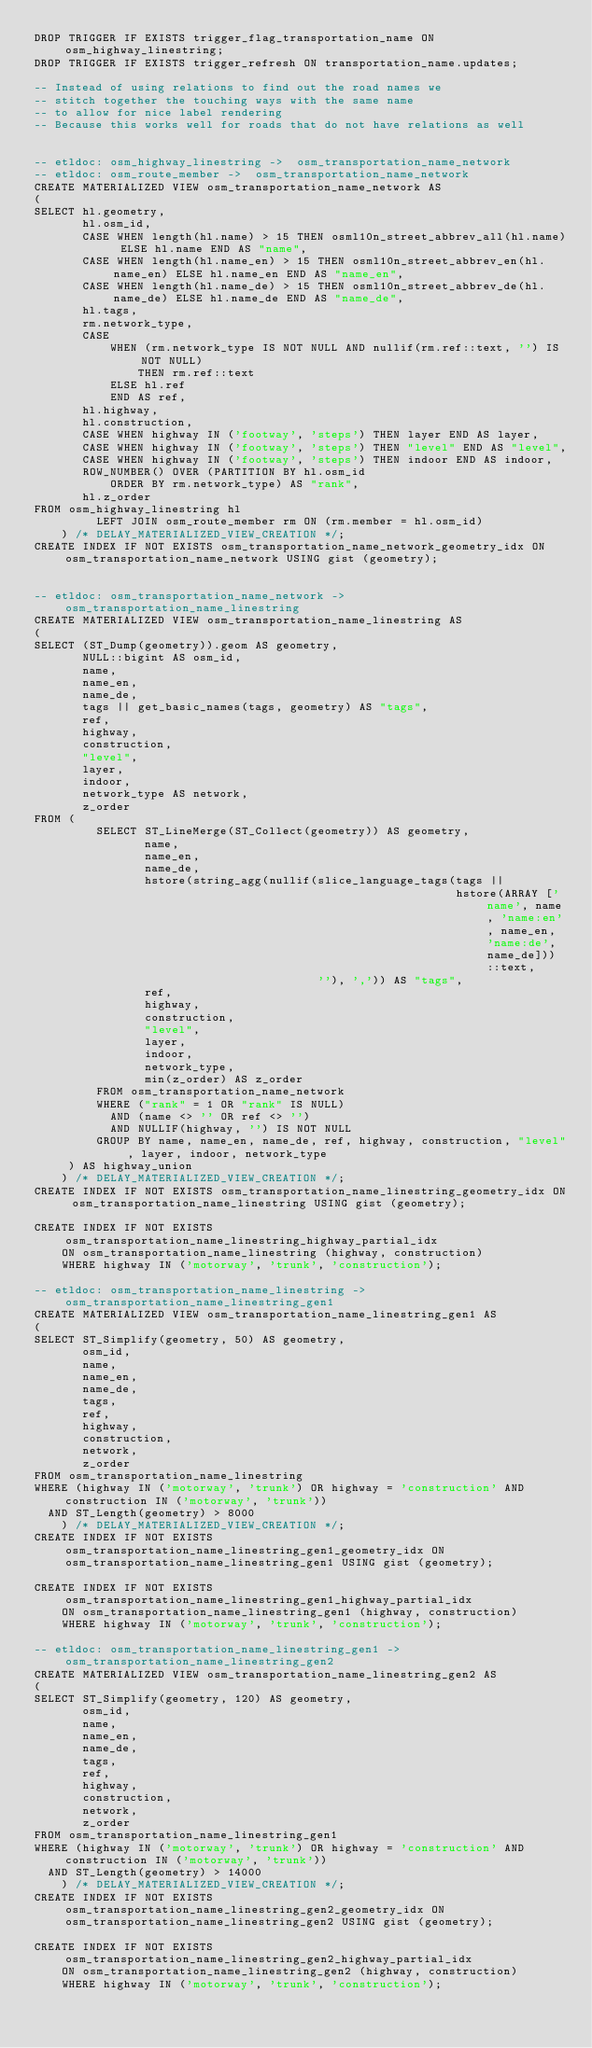<code> <loc_0><loc_0><loc_500><loc_500><_SQL_>DROP TRIGGER IF EXISTS trigger_flag_transportation_name ON osm_highway_linestring;
DROP TRIGGER IF EXISTS trigger_refresh ON transportation_name.updates;

-- Instead of using relations to find out the road names we
-- stitch together the touching ways with the same name
-- to allow for nice label rendering
-- Because this works well for roads that do not have relations as well


-- etldoc: osm_highway_linestring ->  osm_transportation_name_network
-- etldoc: osm_route_member ->  osm_transportation_name_network
CREATE MATERIALIZED VIEW osm_transportation_name_network AS
(
SELECT hl.geometry,
       hl.osm_id,
       CASE WHEN length(hl.name) > 15 THEN osml10n_street_abbrev_all(hl.name) ELSE hl.name END AS "name",
       CASE WHEN length(hl.name_en) > 15 THEN osml10n_street_abbrev_en(hl.name_en) ELSE hl.name_en END AS "name_en",
       CASE WHEN length(hl.name_de) > 15 THEN osml10n_street_abbrev_de(hl.name_de) ELSE hl.name_de END AS "name_de",
       hl.tags,
       rm.network_type,
       CASE
           WHEN (rm.network_type IS NOT NULL AND nullif(rm.ref::text, '') IS NOT NULL)
               THEN rm.ref::text
           ELSE hl.ref
           END AS ref,
       hl.highway,
       hl.construction,
       CASE WHEN highway IN ('footway', 'steps') THEN layer END AS layer,
       CASE WHEN highway IN ('footway', 'steps') THEN "level" END AS "level",
       CASE WHEN highway IN ('footway', 'steps') THEN indoor END AS indoor,
       ROW_NUMBER() OVER (PARTITION BY hl.osm_id
           ORDER BY rm.network_type) AS "rank",
       hl.z_order
FROM osm_highway_linestring hl
         LEFT JOIN osm_route_member rm ON (rm.member = hl.osm_id)
    ) /* DELAY_MATERIALIZED_VIEW_CREATION */;
CREATE INDEX IF NOT EXISTS osm_transportation_name_network_geometry_idx ON osm_transportation_name_network USING gist (geometry);


-- etldoc: osm_transportation_name_network ->  osm_transportation_name_linestring
CREATE MATERIALIZED VIEW osm_transportation_name_linestring AS
(
SELECT (ST_Dump(geometry)).geom AS geometry,
       NULL::bigint AS osm_id,
       name,
       name_en,
       name_de,
       tags || get_basic_names(tags, geometry) AS "tags",
       ref,
       highway,
       construction,
       "level",
       layer,
       indoor,
       network_type AS network,
       z_order
FROM (
         SELECT ST_LineMerge(ST_Collect(geometry)) AS geometry,
                name,
                name_en,
                name_de,
                hstore(string_agg(nullif(slice_language_tags(tags ||
                                                             hstore(ARRAY ['name', name, 'name:en', name_en, 'name:de', name_de]))::text,
                                         ''), ',')) AS "tags",
                ref,
                highway,
                construction,
                "level",
                layer,
                indoor,
                network_type,
                min(z_order) AS z_order
         FROM osm_transportation_name_network
         WHERE ("rank" = 1 OR "rank" IS NULL)
           AND (name <> '' OR ref <> '')
           AND NULLIF(highway, '') IS NOT NULL
         GROUP BY name, name_en, name_de, ref, highway, construction, "level", layer, indoor, network_type
     ) AS highway_union
    ) /* DELAY_MATERIALIZED_VIEW_CREATION */;
CREATE INDEX IF NOT EXISTS osm_transportation_name_linestring_geometry_idx ON osm_transportation_name_linestring USING gist (geometry);

CREATE INDEX IF NOT EXISTS osm_transportation_name_linestring_highway_partial_idx
    ON osm_transportation_name_linestring (highway, construction)
    WHERE highway IN ('motorway', 'trunk', 'construction');

-- etldoc: osm_transportation_name_linestring -> osm_transportation_name_linestring_gen1
CREATE MATERIALIZED VIEW osm_transportation_name_linestring_gen1 AS
(
SELECT ST_Simplify(geometry, 50) AS geometry,
       osm_id,
       name,
       name_en,
       name_de,
       tags,
       ref,
       highway,
       construction,
       network,
       z_order
FROM osm_transportation_name_linestring
WHERE (highway IN ('motorway', 'trunk') OR highway = 'construction' AND construction IN ('motorway', 'trunk'))
  AND ST_Length(geometry) > 8000
    ) /* DELAY_MATERIALIZED_VIEW_CREATION */;
CREATE INDEX IF NOT EXISTS osm_transportation_name_linestring_gen1_geometry_idx ON osm_transportation_name_linestring_gen1 USING gist (geometry);

CREATE INDEX IF NOT EXISTS osm_transportation_name_linestring_gen1_highway_partial_idx
    ON osm_transportation_name_linestring_gen1 (highway, construction)
    WHERE highway IN ('motorway', 'trunk', 'construction');

-- etldoc: osm_transportation_name_linestring_gen1 -> osm_transportation_name_linestring_gen2
CREATE MATERIALIZED VIEW osm_transportation_name_linestring_gen2 AS
(
SELECT ST_Simplify(geometry, 120) AS geometry,
       osm_id,
       name,
       name_en,
       name_de,
       tags,
       ref,
       highway,
       construction,
       network,
       z_order
FROM osm_transportation_name_linestring_gen1
WHERE (highway IN ('motorway', 'trunk') OR highway = 'construction' AND construction IN ('motorway', 'trunk'))
  AND ST_Length(geometry) > 14000
    ) /* DELAY_MATERIALIZED_VIEW_CREATION */;
CREATE INDEX IF NOT EXISTS osm_transportation_name_linestring_gen2_geometry_idx ON osm_transportation_name_linestring_gen2 USING gist (geometry);

CREATE INDEX IF NOT EXISTS osm_transportation_name_linestring_gen2_highway_partial_idx
    ON osm_transportation_name_linestring_gen2 (highway, construction)
    WHERE highway IN ('motorway', 'trunk', 'construction');
</code> 